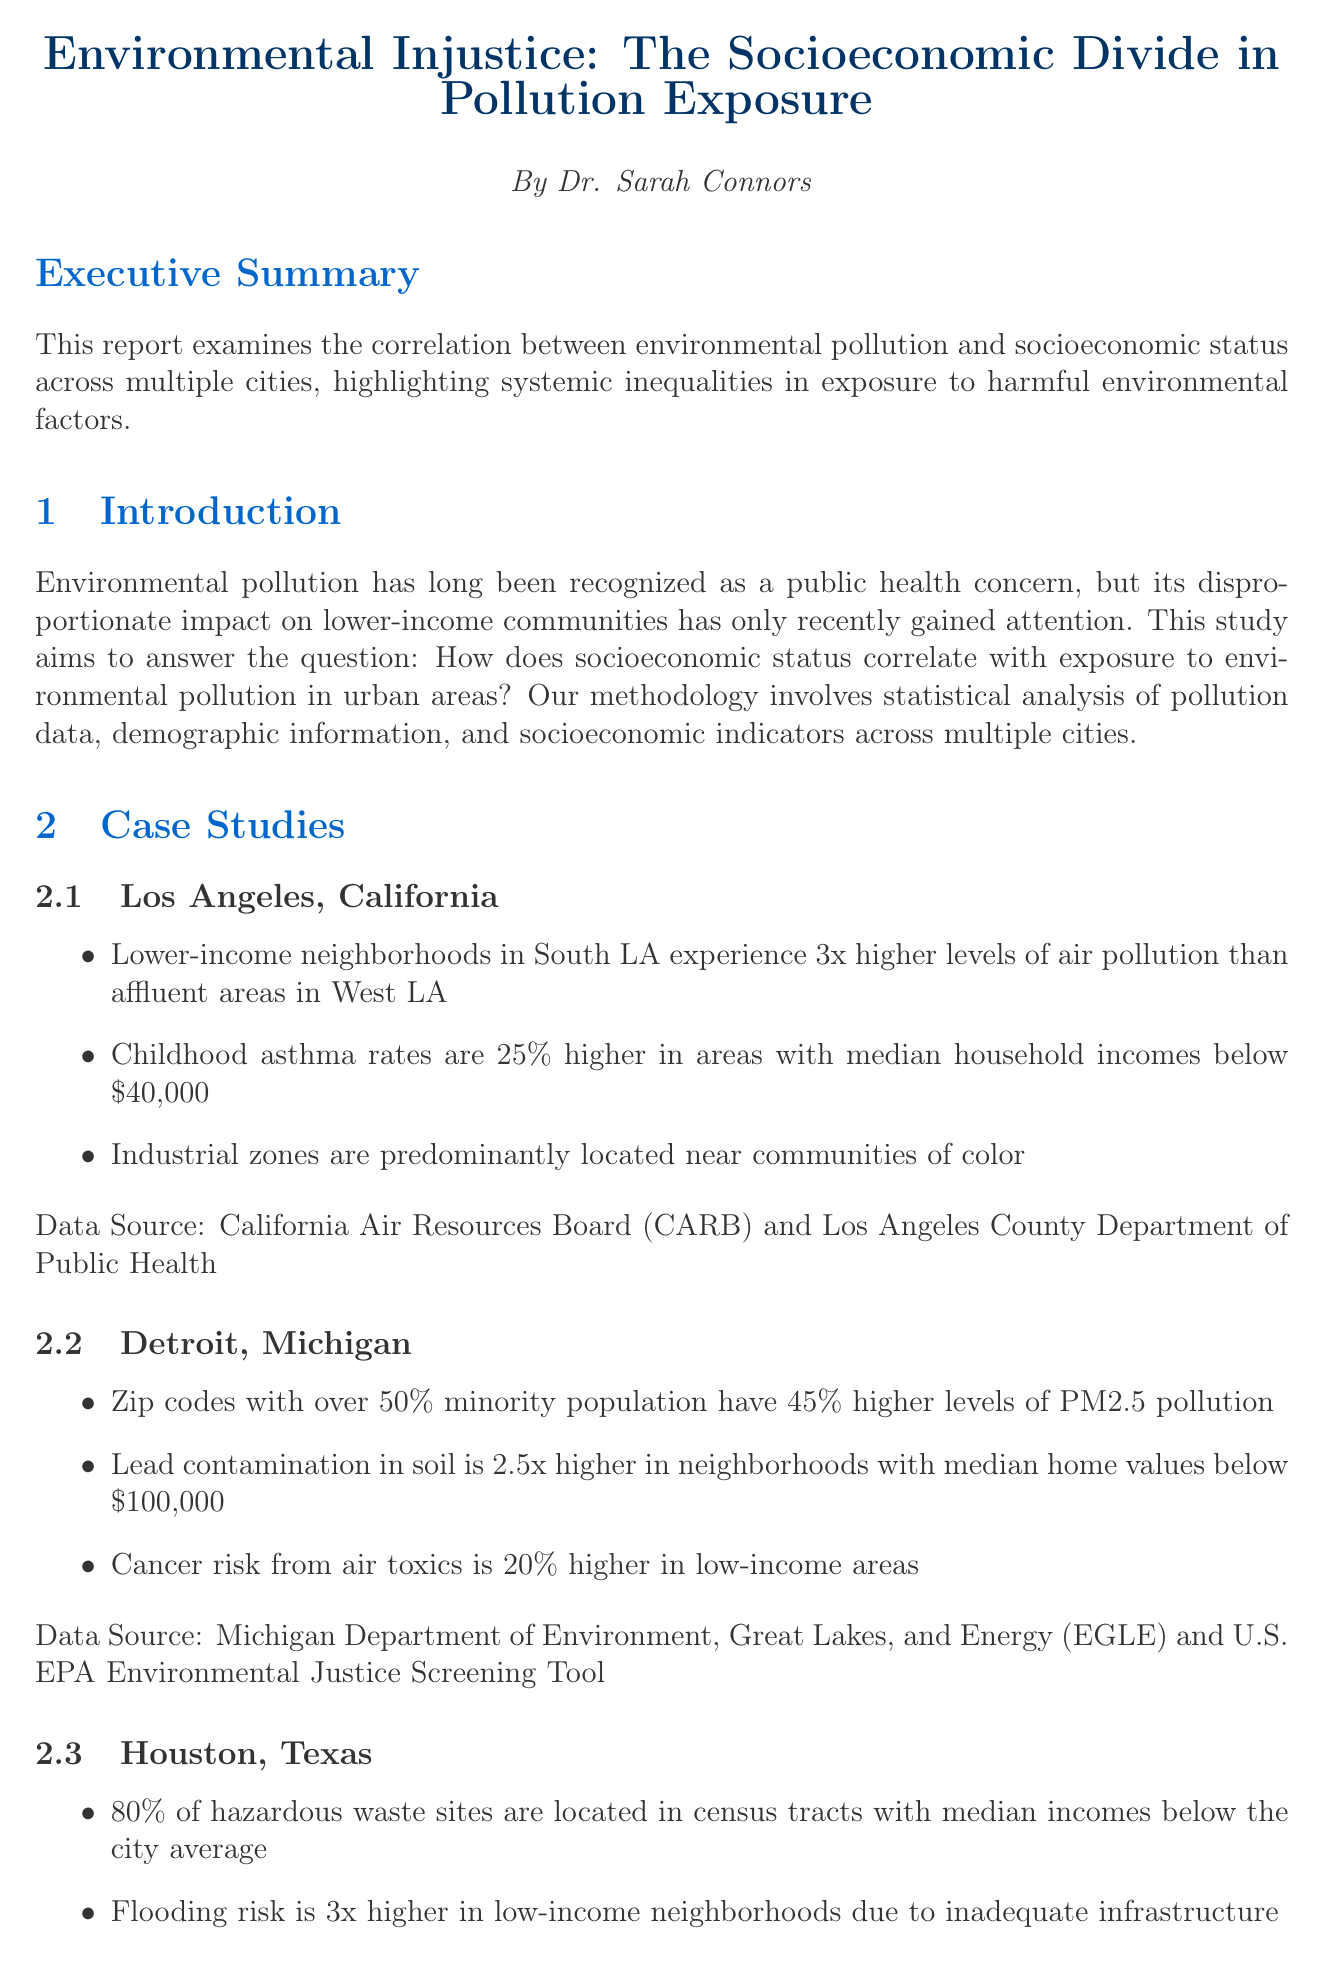what is the title of the report? The title of the report is mentioned at the beginning, highlighting the primary focus of the research.
Answer: Environmental Injustice: The Socioeconomic Divide in Pollution Exposure who authored the report? The author is specified in the document to give credit to the researcher behind the findings.
Answer: Dr. Sarah Connors how much higher is the childhood asthma rate in lower-income areas of Los Angeles? The report provides specific statistics on health outcomes in relation to pollution exposure in different areas.
Answer: 25% which city has a finding of 45% higher PM2.5 pollution in minority neighborhoods? The report includes various case studies detailing specific pollution statistics for selected cities.
Answer: Detroit, Michigan what percentage of hazardous waste sites in Houston are located in low-income areas? The document mentions specific findings relevant to environmental hazards in different socioeconomic contexts.
Answer: 80% what is the estimated annual healthcare costs per capita in low-income communities? The economic analysis section presents key statistics related to the financial impact of pollution exposure.
Answer: $5,000 what is one of the key policy implications suggested in the report? The report outlines several recommendations aimed at addressing the issues identified through data analysis and case studies.
Answer: Strengthen environmental justice considerations in zoning and urban planning what does the report emphasize as necessary to address environmental disparities? The conclusion highlights the overarching theme of the report regarding the need for action to mitigate findings.
Answer: A multifaceted approach 